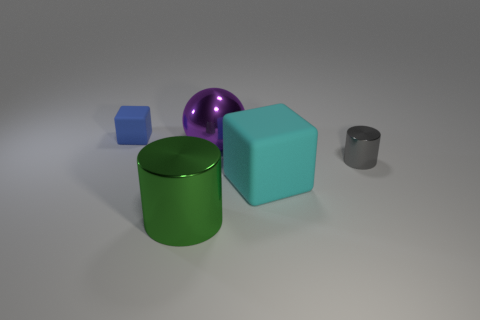Add 1 tiny cylinders. How many objects exist? 6 Subtract all balls. How many objects are left? 4 Subtract all cubes. Subtract all large purple things. How many objects are left? 2 Add 5 small gray cylinders. How many small gray cylinders are left? 6 Add 1 large green shiny objects. How many large green shiny objects exist? 2 Subtract 0 green cubes. How many objects are left? 5 